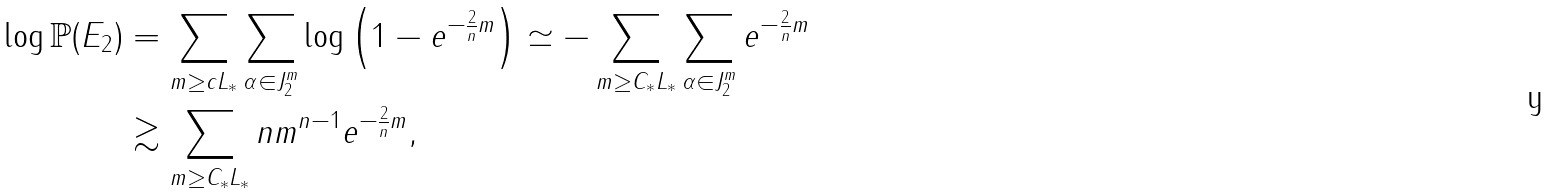Convert formula to latex. <formula><loc_0><loc_0><loc_500><loc_500>\log \mathbb { P } ( E _ { 2 } ) & = \sum _ { m \geq c L _ { * } } \sum _ { \alpha \in J _ { 2 } ^ { m } } \log \left ( 1 - e ^ { - \frac { 2 } { n } m } \right ) \simeq - \sum _ { m \geq C _ { * } L _ { * } } \sum _ { \alpha \in J _ { 2 } ^ { m } } e ^ { - \frac { 2 } { n } m } \\ & \gtrsim \sum _ { m \geq C _ { * } L _ { * } } n m ^ { n - 1 } e ^ { - \frac { 2 } { n } m } ,</formula> 